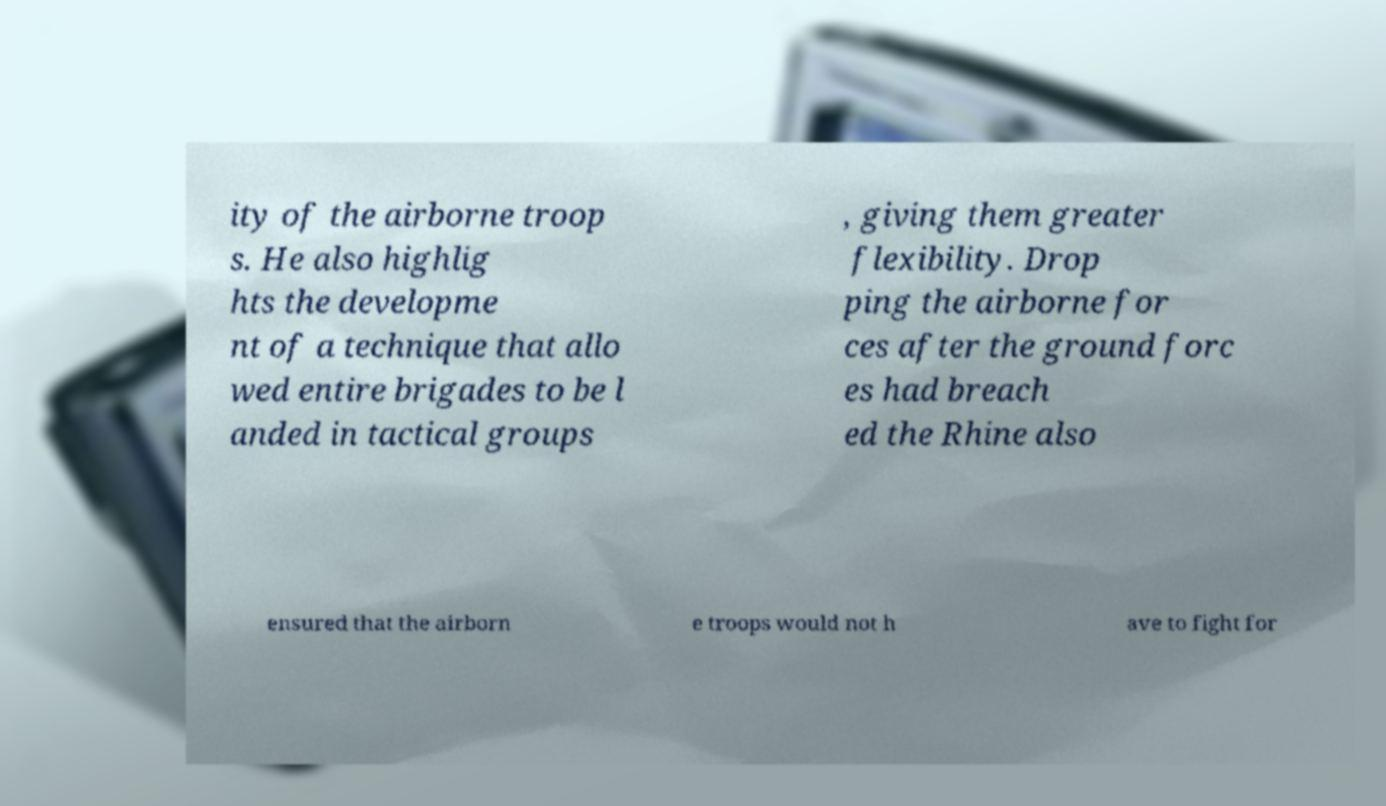Could you extract and type out the text from this image? ity of the airborne troop s. He also highlig hts the developme nt of a technique that allo wed entire brigades to be l anded in tactical groups , giving them greater flexibility. Drop ping the airborne for ces after the ground forc es had breach ed the Rhine also ensured that the airborn e troops would not h ave to fight for 